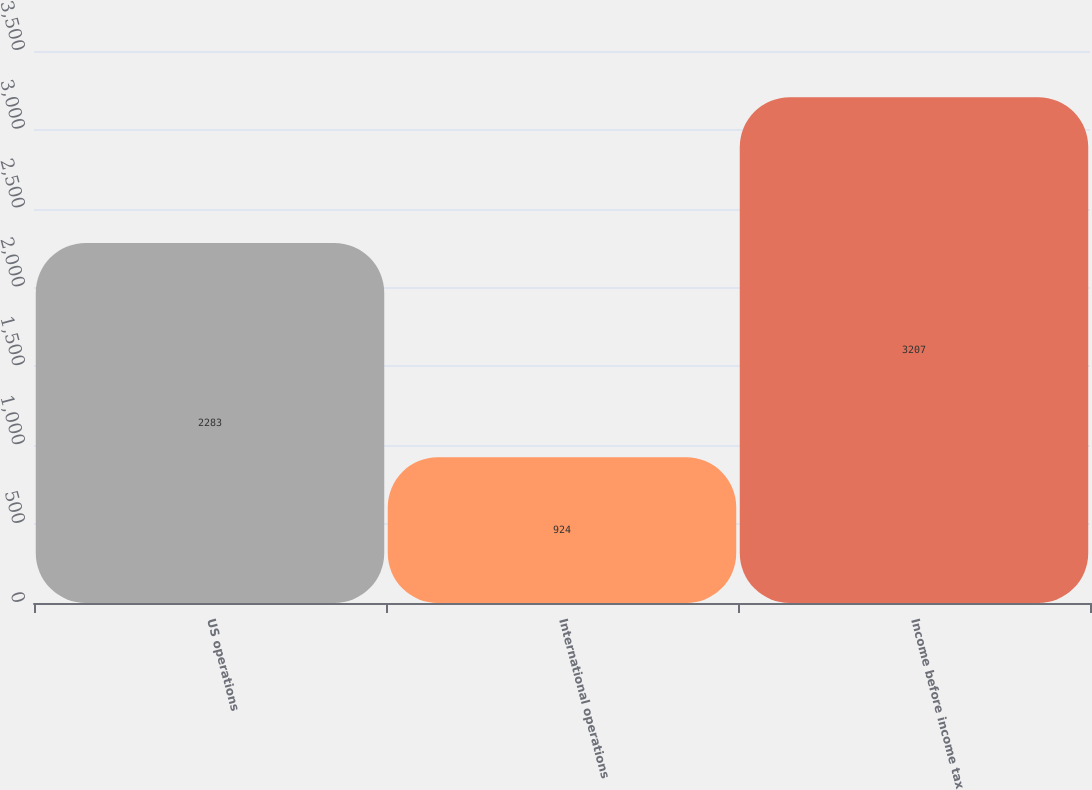<chart> <loc_0><loc_0><loc_500><loc_500><bar_chart><fcel>US operations<fcel>International operations<fcel>Income before income tax<nl><fcel>2283<fcel>924<fcel>3207<nl></chart> 